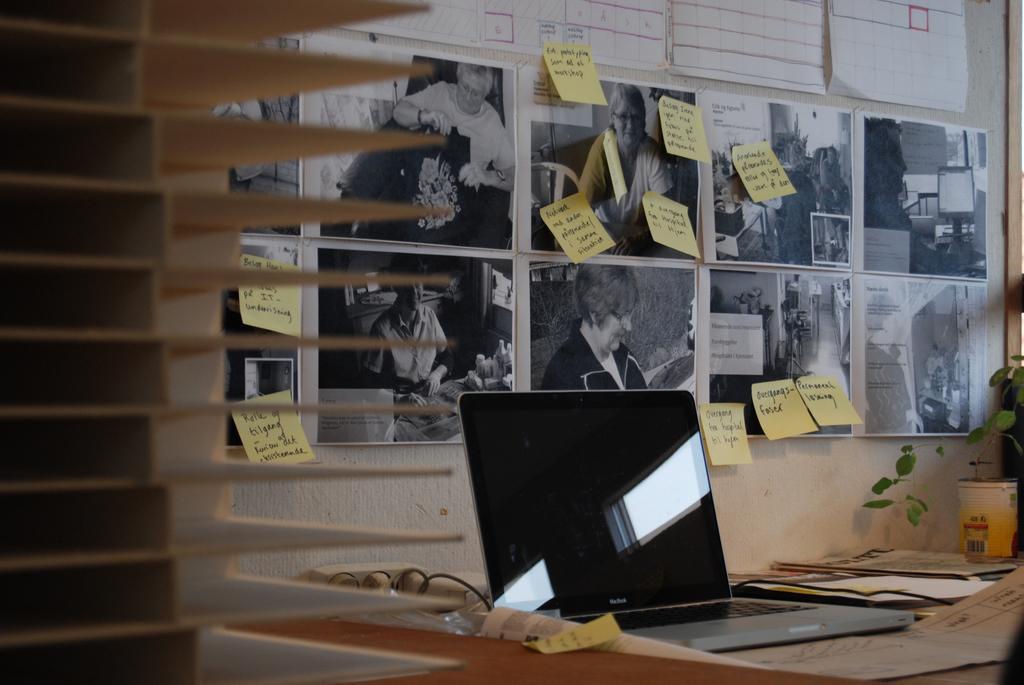Could you give a brief overview of what you see in this image? A pictures on wall. These notes and this posters are also on wall. On this table there is a laptop and paper. Far there is a plant. 